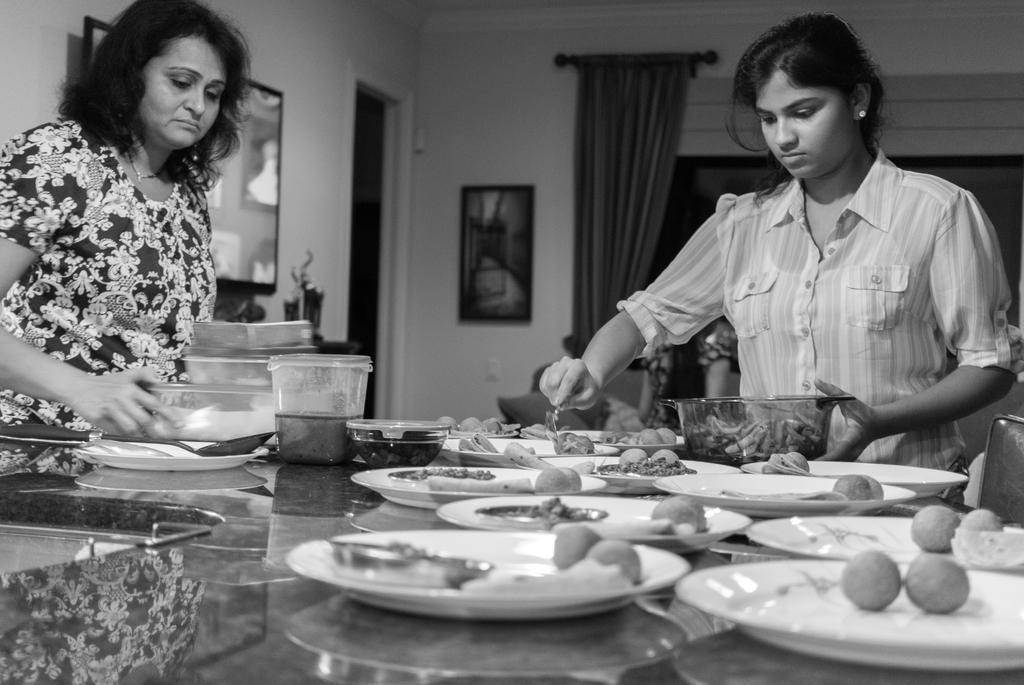How would you summarize this image in a sentence or two? In this picture, there are two women standing around a table on which some food items in the plates are placed on the table. Both of them are serving them into bowls. In the background there is a curtain and a photograph to the wall. 